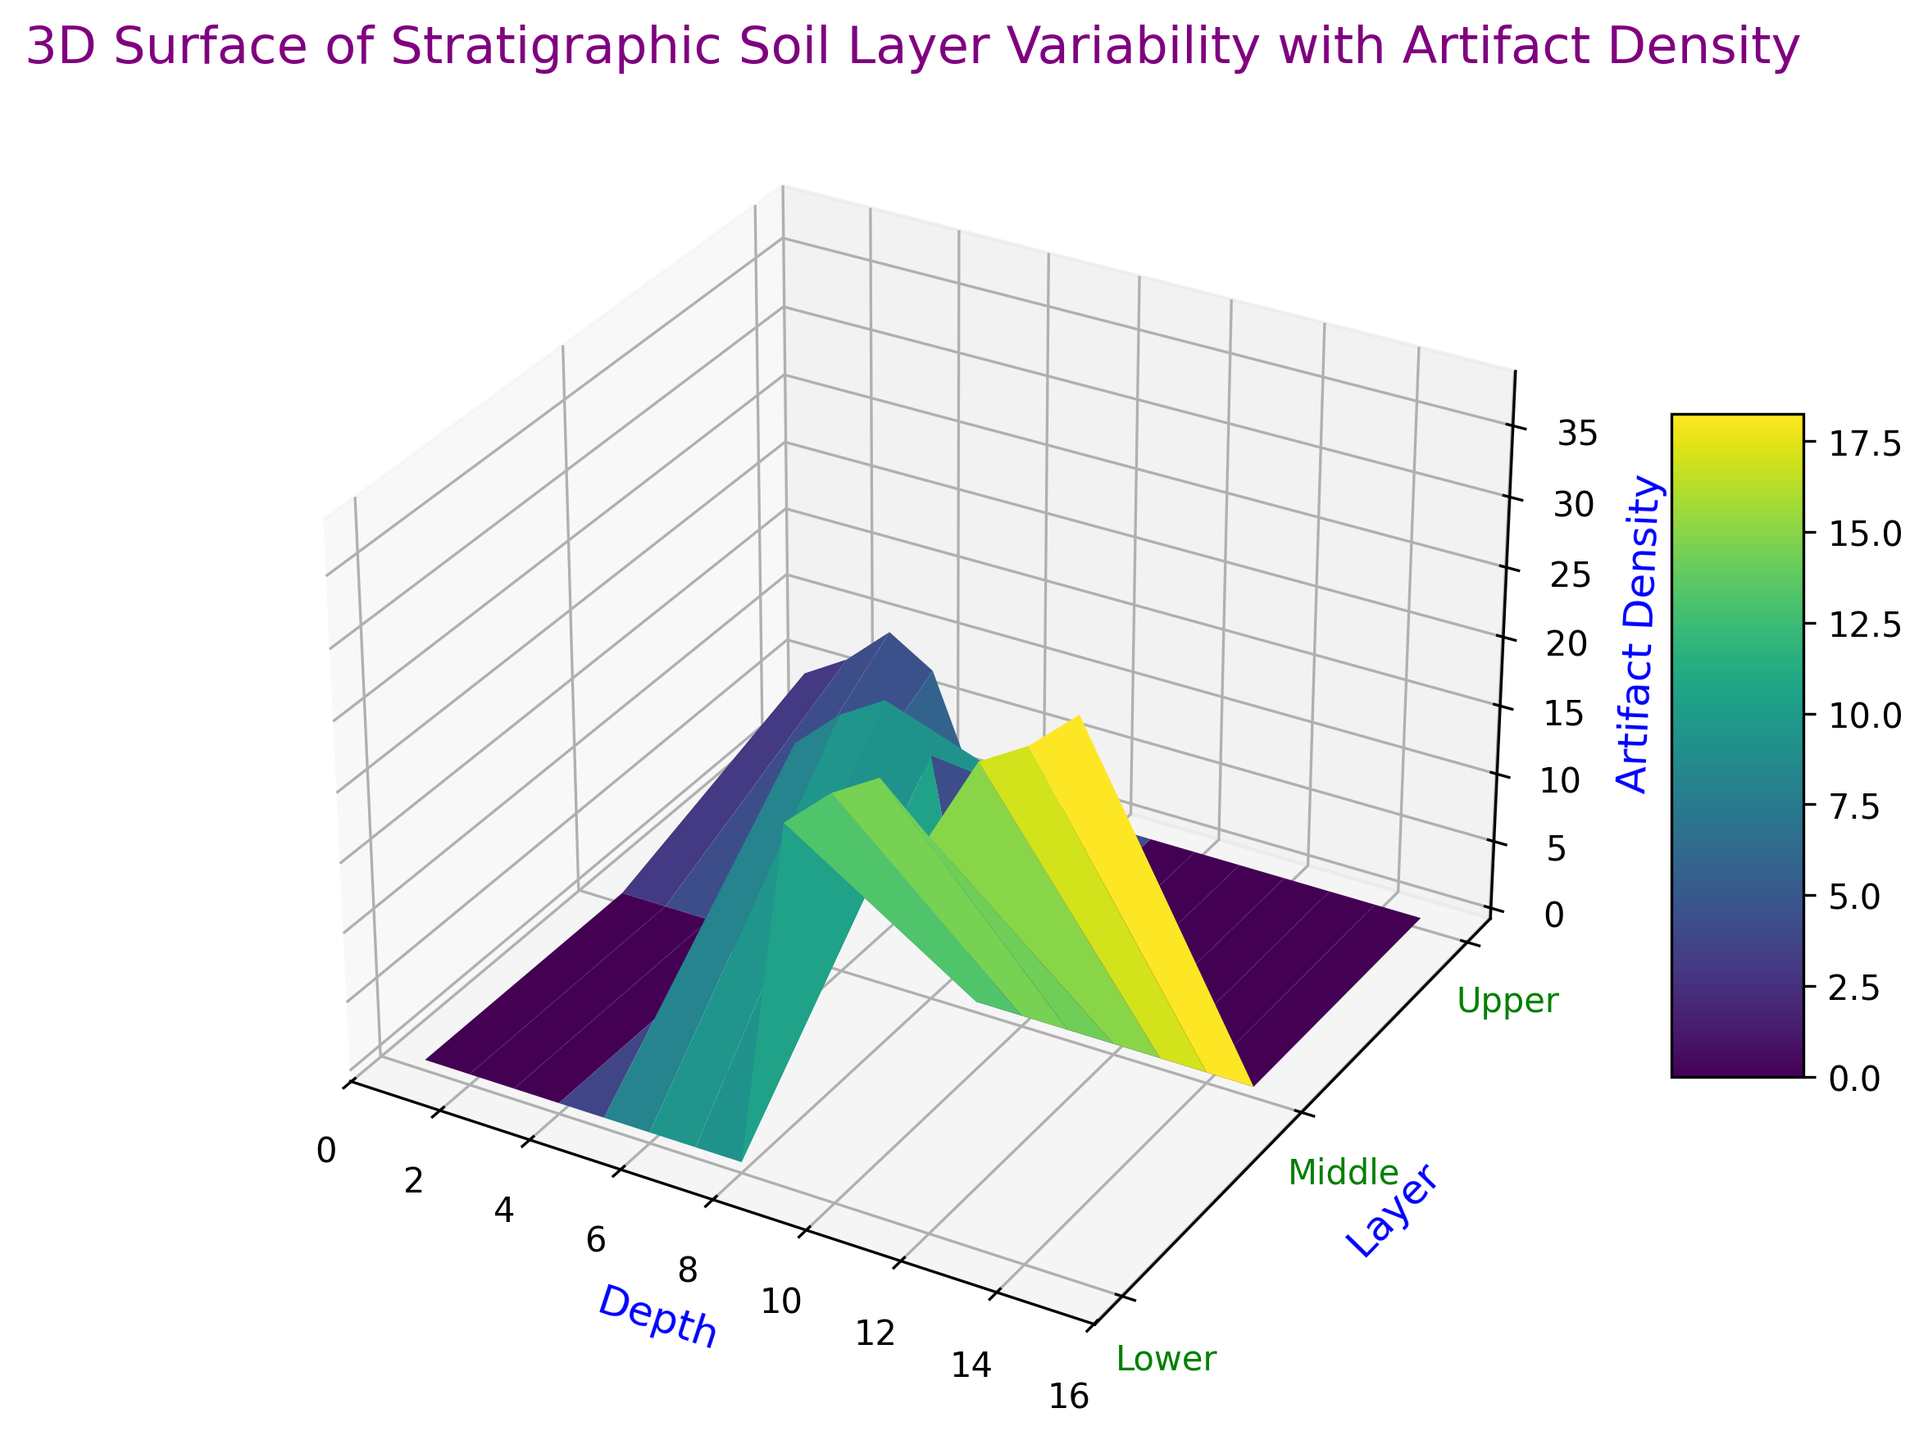How does the artifact density at the 8th depth in the Middle layer compare to the artifact density at the 6th depth in the same layer? The 3D plot shows the artifact density for different depths and layers. By looking at the Middle layer, at the 8th depth, the artifact density is 17, while at the 6th depth, it is 18. So, artifact density at 8th depth is less than at the 6th depth.
Answer: Less What is the sum of artifact densities for all the Upper layer depths? To determine the sum of artifact densities in the Upper layer, add the values: 5 + 7 + 10 + 8, resulting in a sum of 30.
Answer: 30 Which layer shows the highest artifact density and at what depth does it occur? By examining the 3D plot, the highest artifact density in the Lower layer is at depth 15 with a density of 38. Comparatively, this is the highest among all layers and depths.
Answer: Lower layer at depth 15 How does the artifact density change as you go from Upper to Lower layers? Observing the plot, the artifact density increases from Upper to Middle, and from Middle to Lower layers. The Upper layer densities range from 5 to 10, Middle ranges from 15 to 20, and Lower ranges from 25 to 38.
Answer: Increases Which depth in the Lower layer shows the smallest artifact density, and what is its value? Inspecting the Lower layer on the plot, the smallest artifact density appears at depth 9 with a value of 25.
Answer: Depth 9 with 25 Compare the average artifact density of the Middle layer to that of the Lower layer. Which is greater? The average artifact density for the Middle layer is calculated by summing (15 + 18 + 20 + 17) and dividing by 4, resulting in 17.5. The Lower layer sum (25 + 28 + 30 + 27 + 33 + 35 + 38) divided by 7 gives an average of around 31.71. Therefore, the Lower layer has a greater average artifact density.
Answer: Lower layer What depth in the Middle layer has the highest artifact density and what is the value? By reviewing the 3D plot for the Middle layer, the highest artifact density is at depth 7 with a value of 20.
Answer: Depth 7 with 20 What does the color gradient on the plot indicate? The color gradient in the 3D plot, ranging from lighter to darker shades, indicates varying artifact densities, with lighter colors representing lower densities and darker colors representing higher densities.
Answer: Artifact densities On which layer does the artifact density first reach or exceed 30, at what depth, and what does this indicate about stratification? The depth where artifact density first reaches or exceeds 30 is at depth 11 in the Lower layer. This indicates a significant increase in artifact findings as we go deeper, reflecting stratigraphic accumulation over time.
Answer: Lower layer at depth 11 What is the general trend in artifact density as depth increases within each layer? Examining the plot, the artifact density generally increases as depth increases within each layer, particularly notable in the Lower layer. This suggests increased archaeological activity or deposition in deeper layers.
Answer: Increases 